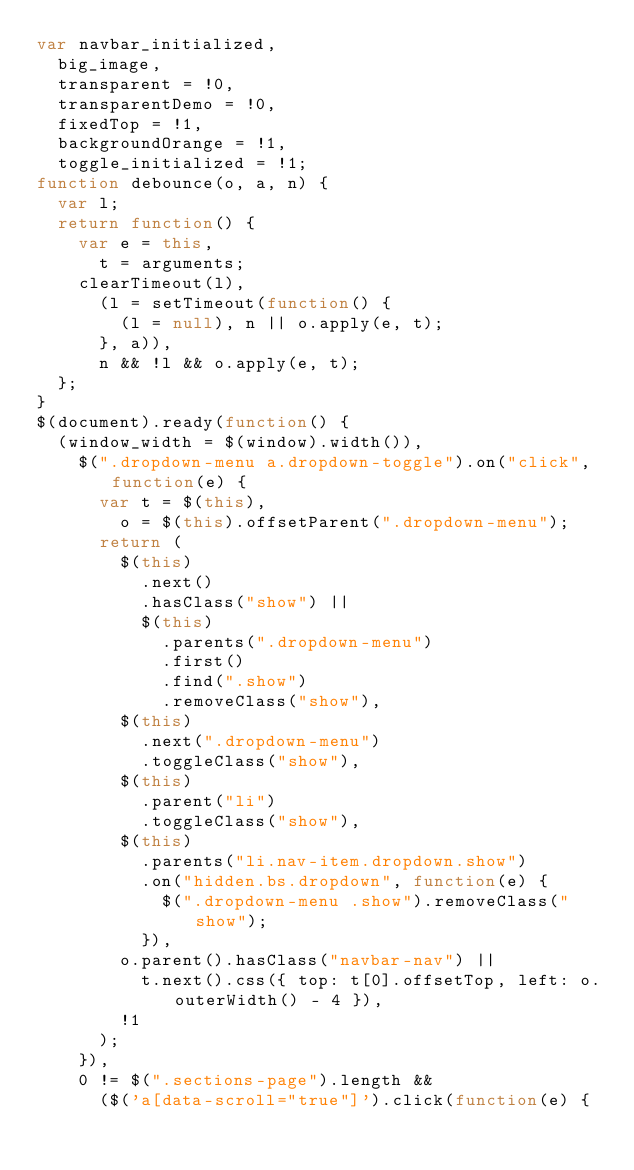<code> <loc_0><loc_0><loc_500><loc_500><_JavaScript_>var navbar_initialized,
  big_image,
  transparent = !0,
  transparentDemo = !0,
  fixedTop = !1,
  backgroundOrange = !1,
  toggle_initialized = !1;
function debounce(o, a, n) {
  var l;
  return function() {
    var e = this,
      t = arguments;
    clearTimeout(l),
      (l = setTimeout(function() {
        (l = null), n || o.apply(e, t);
      }, a)),
      n && !l && o.apply(e, t);
  };
}
$(document).ready(function() {
  (window_width = $(window).width()),
    $(".dropdown-menu a.dropdown-toggle").on("click", function(e) {
      var t = $(this),
        o = $(this).offsetParent(".dropdown-menu");
      return (
        $(this)
          .next()
          .hasClass("show") ||
          $(this)
            .parents(".dropdown-menu")
            .first()
            .find(".show")
            .removeClass("show"),
        $(this)
          .next(".dropdown-menu")
          .toggleClass("show"),
        $(this)
          .parent("li")
          .toggleClass("show"),
        $(this)
          .parents("li.nav-item.dropdown.show")
          .on("hidden.bs.dropdown", function(e) {
            $(".dropdown-menu .show").removeClass("show");
          }),
        o.parent().hasClass("navbar-nav") ||
          t.next().css({ top: t[0].offsetTop, left: o.outerWidth() - 4 }),
        !1
      );
    }),
    0 != $(".sections-page").length &&
      ($('a[data-scroll="true"]').click(function(e) {</code> 